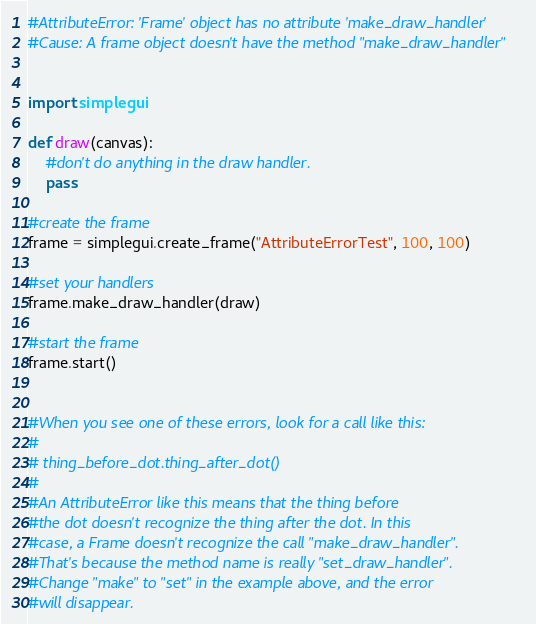Convert code to text. <code><loc_0><loc_0><loc_500><loc_500><_Python_>#AttributeError: 'Frame' object has no attribute 'make_draw_handler'
#Cause: A frame object doesn't have the method "make_draw_handler"


import simplegui

def draw(canvas):
    #don't do anything in the draw handler. 
    pass 

#create the frame
frame = simplegui.create_frame("AttributeErrorTest", 100, 100)

#set your handlers
frame.make_draw_handler(draw)

#start the frame
frame.start()


#When you see one of these errors, look for a call like this:
#
# thing_before_dot.thing_after_dot()
#
#An AttributeError like this means that the thing before
#the dot doesn't recognize the thing after the dot. In this
#case, a Frame doesn't recognize the call "make_draw_handler". 
#That's because the method name is really "set_draw_handler". 
#Change "make" to "set" in the example above, and the error
#will disappear.

</code> 